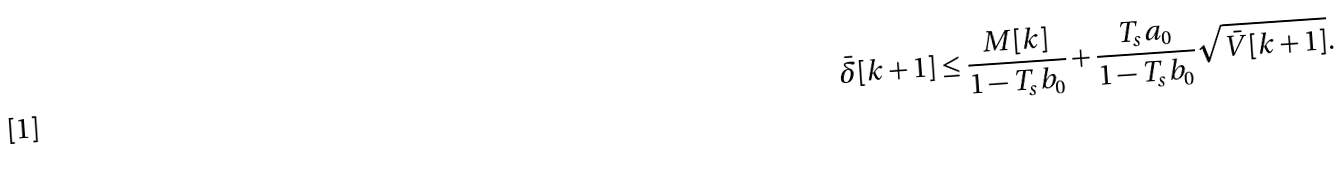Convert formula to latex. <formula><loc_0><loc_0><loc_500><loc_500>\bar { \delta } [ k + 1 ] \leq \frac { M [ k ] } { 1 - T _ { s } b _ { 0 } } + \frac { T _ { s } a _ { 0 } } { 1 - T _ { s } b _ { 0 } } \sqrt { \bar { V } [ k + 1 ] } .</formula> 